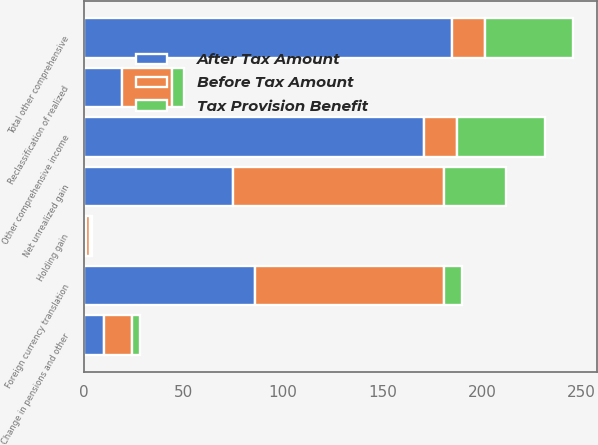Convert chart. <chart><loc_0><loc_0><loc_500><loc_500><stacked_bar_chart><ecel><fcel>Change in pensions and other<fcel>Foreign currency translation<fcel>Holding gain<fcel>Reclassification of realized<fcel>Net unrealized gain<fcel>Other comprehensive income<fcel>Total other comprehensive<nl><fcel>Before Tax Amount<fcel>14<fcel>95<fcel>2<fcel>25<fcel>106<fcel>16.5<fcel>16.5<nl><fcel>Tax Provision Benefit<fcel>4<fcel>9<fcel>1<fcel>6<fcel>31<fcel>44<fcel>44<nl><fcel>After Tax Amount<fcel>10<fcel>86<fcel>1<fcel>19<fcel>75<fcel>171<fcel>185<nl></chart> 